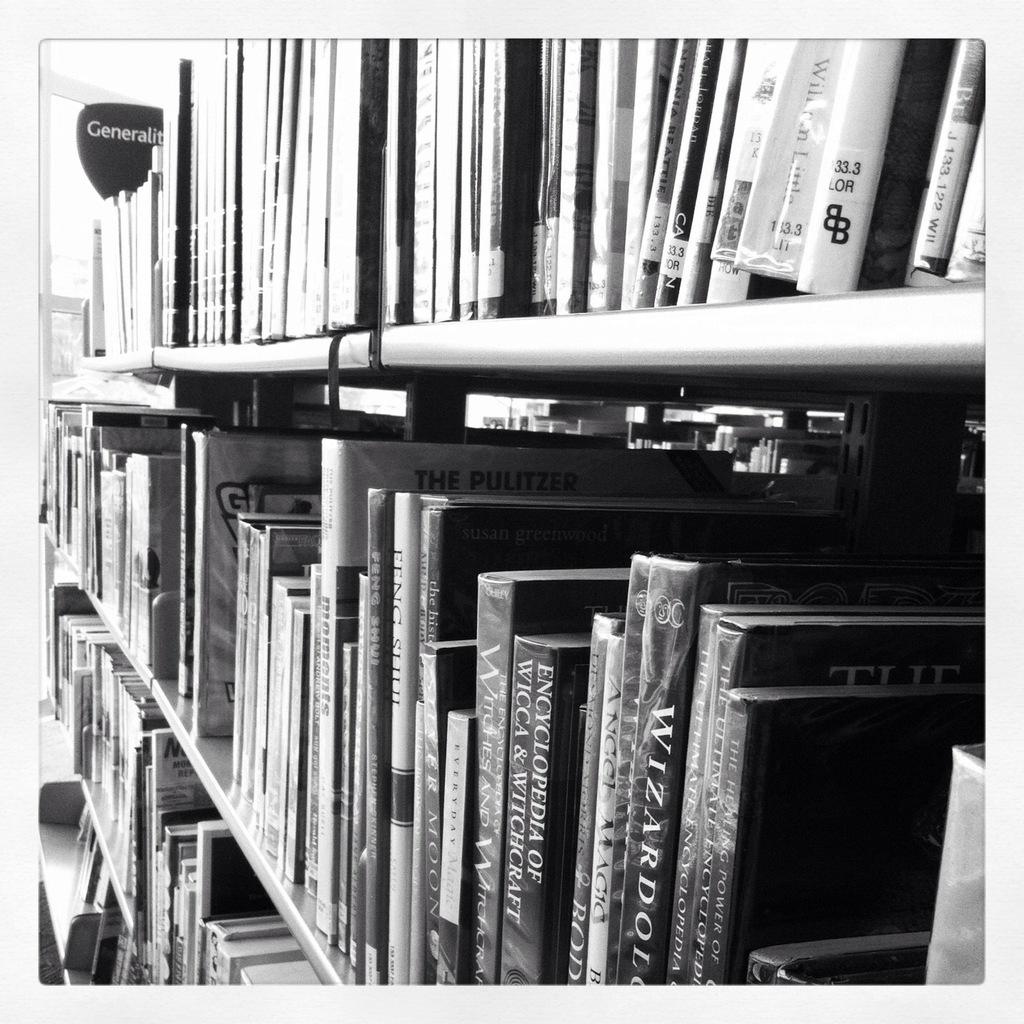<image>
Summarize the visual content of the image. An encyclopedia about Wicca and Witchcraft sits among other books on a library shelf. 